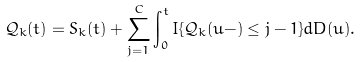<formula> <loc_0><loc_0><loc_500><loc_500>\mathcal { Q } _ { k } ( t ) = S _ { k } ( t ) + \sum _ { j = 1 } ^ { C } \int _ { 0 } ^ { t } I \{ \mathcal { Q } _ { k } ( u - ) \leq j - 1 \} d D ( u ) .</formula> 